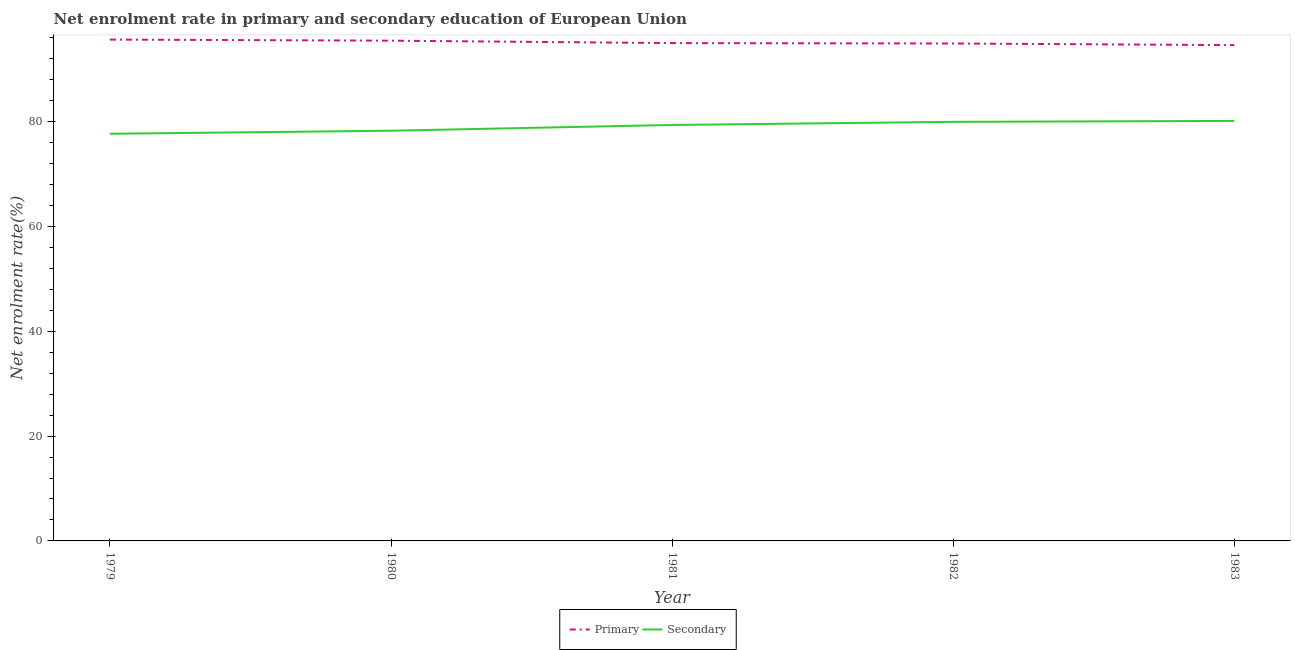Does the line corresponding to enrollment rate in primary education intersect with the line corresponding to enrollment rate in secondary education?
Provide a succinct answer. No. Is the number of lines equal to the number of legend labels?
Give a very brief answer. Yes. What is the enrollment rate in primary education in 1981?
Provide a short and direct response. 94.94. Across all years, what is the maximum enrollment rate in secondary education?
Offer a very short reply. 80.1. Across all years, what is the minimum enrollment rate in primary education?
Your answer should be very brief. 94.56. In which year was the enrollment rate in primary education maximum?
Keep it short and to the point. 1979. What is the total enrollment rate in secondary education in the graph?
Your answer should be compact. 395.23. What is the difference between the enrollment rate in secondary education in 1979 and that in 1983?
Offer a very short reply. -2.45. What is the difference between the enrollment rate in primary education in 1983 and the enrollment rate in secondary education in 1980?
Ensure brevity in your answer.  16.33. What is the average enrollment rate in primary education per year?
Provide a short and direct response. 95.08. In the year 1981, what is the difference between the enrollment rate in secondary education and enrollment rate in primary education?
Make the answer very short. -15.62. What is the ratio of the enrollment rate in secondary education in 1981 to that in 1983?
Your response must be concise. 0.99. Is the enrollment rate in primary education in 1979 less than that in 1983?
Ensure brevity in your answer.  No. Is the difference between the enrollment rate in primary education in 1979 and 1981 greater than the difference between the enrollment rate in secondary education in 1979 and 1981?
Provide a succinct answer. Yes. What is the difference between the highest and the second highest enrollment rate in primary education?
Ensure brevity in your answer.  0.21. What is the difference between the highest and the lowest enrollment rate in secondary education?
Your response must be concise. 2.45. In how many years, is the enrollment rate in primary education greater than the average enrollment rate in primary education taken over all years?
Offer a very short reply. 2. Does the enrollment rate in secondary education monotonically increase over the years?
Your answer should be compact. Yes. Is the enrollment rate in primary education strictly greater than the enrollment rate in secondary education over the years?
Keep it short and to the point. Yes. How many lines are there?
Ensure brevity in your answer.  2. How many years are there in the graph?
Your answer should be compact. 5. Are the values on the major ticks of Y-axis written in scientific E-notation?
Offer a very short reply. No. Does the graph contain grids?
Your answer should be very brief. No. How many legend labels are there?
Your response must be concise. 2. How are the legend labels stacked?
Your response must be concise. Horizontal. What is the title of the graph?
Provide a short and direct response. Net enrolment rate in primary and secondary education of European Union. Does "Money lenders" appear as one of the legend labels in the graph?
Your answer should be compact. No. What is the label or title of the Y-axis?
Your answer should be very brief. Net enrolment rate(%). What is the Net enrolment rate(%) in Primary in 1979?
Your response must be concise. 95.61. What is the Net enrolment rate(%) of Secondary in 1979?
Make the answer very short. 77.65. What is the Net enrolment rate(%) of Primary in 1980?
Provide a succinct answer. 95.4. What is the Net enrolment rate(%) in Secondary in 1980?
Make the answer very short. 78.23. What is the Net enrolment rate(%) of Primary in 1981?
Your answer should be very brief. 94.94. What is the Net enrolment rate(%) in Secondary in 1981?
Make the answer very short. 79.33. What is the Net enrolment rate(%) in Primary in 1982?
Your answer should be very brief. 94.87. What is the Net enrolment rate(%) in Secondary in 1982?
Offer a terse response. 79.92. What is the Net enrolment rate(%) of Primary in 1983?
Your response must be concise. 94.56. What is the Net enrolment rate(%) of Secondary in 1983?
Give a very brief answer. 80.1. Across all years, what is the maximum Net enrolment rate(%) of Primary?
Offer a terse response. 95.61. Across all years, what is the maximum Net enrolment rate(%) in Secondary?
Your answer should be compact. 80.1. Across all years, what is the minimum Net enrolment rate(%) of Primary?
Your response must be concise. 94.56. Across all years, what is the minimum Net enrolment rate(%) in Secondary?
Provide a succinct answer. 77.65. What is the total Net enrolment rate(%) of Primary in the graph?
Your response must be concise. 475.38. What is the total Net enrolment rate(%) in Secondary in the graph?
Make the answer very short. 395.23. What is the difference between the Net enrolment rate(%) in Primary in 1979 and that in 1980?
Ensure brevity in your answer.  0.21. What is the difference between the Net enrolment rate(%) of Secondary in 1979 and that in 1980?
Provide a short and direct response. -0.58. What is the difference between the Net enrolment rate(%) of Primary in 1979 and that in 1981?
Your response must be concise. 0.67. What is the difference between the Net enrolment rate(%) in Secondary in 1979 and that in 1981?
Ensure brevity in your answer.  -1.68. What is the difference between the Net enrolment rate(%) in Primary in 1979 and that in 1982?
Keep it short and to the point. 0.75. What is the difference between the Net enrolment rate(%) of Secondary in 1979 and that in 1982?
Provide a succinct answer. -2.27. What is the difference between the Net enrolment rate(%) of Primary in 1979 and that in 1983?
Provide a short and direct response. 1.06. What is the difference between the Net enrolment rate(%) of Secondary in 1979 and that in 1983?
Offer a very short reply. -2.45. What is the difference between the Net enrolment rate(%) in Primary in 1980 and that in 1981?
Make the answer very short. 0.46. What is the difference between the Net enrolment rate(%) of Secondary in 1980 and that in 1981?
Offer a very short reply. -1.1. What is the difference between the Net enrolment rate(%) of Primary in 1980 and that in 1982?
Your answer should be very brief. 0.54. What is the difference between the Net enrolment rate(%) of Secondary in 1980 and that in 1982?
Provide a succinct answer. -1.69. What is the difference between the Net enrolment rate(%) in Primary in 1980 and that in 1983?
Provide a succinct answer. 0.85. What is the difference between the Net enrolment rate(%) of Secondary in 1980 and that in 1983?
Offer a very short reply. -1.87. What is the difference between the Net enrolment rate(%) of Primary in 1981 and that in 1982?
Give a very brief answer. 0.08. What is the difference between the Net enrolment rate(%) of Secondary in 1981 and that in 1982?
Your answer should be compact. -0.6. What is the difference between the Net enrolment rate(%) of Primary in 1981 and that in 1983?
Your answer should be very brief. 0.39. What is the difference between the Net enrolment rate(%) in Secondary in 1981 and that in 1983?
Ensure brevity in your answer.  -0.77. What is the difference between the Net enrolment rate(%) of Primary in 1982 and that in 1983?
Offer a very short reply. 0.31. What is the difference between the Net enrolment rate(%) in Secondary in 1982 and that in 1983?
Offer a very short reply. -0.18. What is the difference between the Net enrolment rate(%) of Primary in 1979 and the Net enrolment rate(%) of Secondary in 1980?
Make the answer very short. 17.38. What is the difference between the Net enrolment rate(%) in Primary in 1979 and the Net enrolment rate(%) in Secondary in 1981?
Provide a short and direct response. 16.29. What is the difference between the Net enrolment rate(%) in Primary in 1979 and the Net enrolment rate(%) in Secondary in 1982?
Your answer should be compact. 15.69. What is the difference between the Net enrolment rate(%) in Primary in 1979 and the Net enrolment rate(%) in Secondary in 1983?
Offer a very short reply. 15.51. What is the difference between the Net enrolment rate(%) in Primary in 1980 and the Net enrolment rate(%) in Secondary in 1981?
Ensure brevity in your answer.  16.08. What is the difference between the Net enrolment rate(%) in Primary in 1980 and the Net enrolment rate(%) in Secondary in 1982?
Your answer should be very brief. 15.48. What is the difference between the Net enrolment rate(%) in Primary in 1980 and the Net enrolment rate(%) in Secondary in 1983?
Provide a succinct answer. 15.3. What is the difference between the Net enrolment rate(%) of Primary in 1981 and the Net enrolment rate(%) of Secondary in 1982?
Offer a very short reply. 15.02. What is the difference between the Net enrolment rate(%) of Primary in 1981 and the Net enrolment rate(%) of Secondary in 1983?
Your answer should be very brief. 14.84. What is the difference between the Net enrolment rate(%) of Primary in 1982 and the Net enrolment rate(%) of Secondary in 1983?
Offer a very short reply. 14.77. What is the average Net enrolment rate(%) in Primary per year?
Offer a very short reply. 95.08. What is the average Net enrolment rate(%) in Secondary per year?
Provide a short and direct response. 79.05. In the year 1979, what is the difference between the Net enrolment rate(%) of Primary and Net enrolment rate(%) of Secondary?
Ensure brevity in your answer.  17.96. In the year 1980, what is the difference between the Net enrolment rate(%) of Primary and Net enrolment rate(%) of Secondary?
Your response must be concise. 17.17. In the year 1981, what is the difference between the Net enrolment rate(%) in Primary and Net enrolment rate(%) in Secondary?
Ensure brevity in your answer.  15.62. In the year 1982, what is the difference between the Net enrolment rate(%) in Primary and Net enrolment rate(%) in Secondary?
Offer a very short reply. 14.94. In the year 1983, what is the difference between the Net enrolment rate(%) in Primary and Net enrolment rate(%) in Secondary?
Provide a succinct answer. 14.46. What is the ratio of the Net enrolment rate(%) in Secondary in 1979 to that in 1981?
Ensure brevity in your answer.  0.98. What is the ratio of the Net enrolment rate(%) in Primary in 1979 to that in 1982?
Your answer should be very brief. 1.01. What is the ratio of the Net enrolment rate(%) of Secondary in 1979 to that in 1982?
Offer a terse response. 0.97. What is the ratio of the Net enrolment rate(%) of Primary in 1979 to that in 1983?
Give a very brief answer. 1.01. What is the ratio of the Net enrolment rate(%) of Secondary in 1979 to that in 1983?
Offer a very short reply. 0.97. What is the ratio of the Net enrolment rate(%) of Primary in 1980 to that in 1981?
Provide a succinct answer. 1. What is the ratio of the Net enrolment rate(%) in Secondary in 1980 to that in 1981?
Ensure brevity in your answer.  0.99. What is the ratio of the Net enrolment rate(%) of Secondary in 1980 to that in 1982?
Offer a very short reply. 0.98. What is the ratio of the Net enrolment rate(%) in Primary in 1980 to that in 1983?
Provide a short and direct response. 1.01. What is the ratio of the Net enrolment rate(%) of Secondary in 1980 to that in 1983?
Provide a succinct answer. 0.98. What is the ratio of the Net enrolment rate(%) of Primary in 1981 to that in 1982?
Ensure brevity in your answer.  1. What is the ratio of the Net enrolment rate(%) of Primary in 1981 to that in 1983?
Your response must be concise. 1. What is the ratio of the Net enrolment rate(%) of Secondary in 1981 to that in 1983?
Your answer should be compact. 0.99. What is the difference between the highest and the second highest Net enrolment rate(%) in Primary?
Provide a short and direct response. 0.21. What is the difference between the highest and the second highest Net enrolment rate(%) of Secondary?
Provide a succinct answer. 0.18. What is the difference between the highest and the lowest Net enrolment rate(%) in Primary?
Ensure brevity in your answer.  1.06. What is the difference between the highest and the lowest Net enrolment rate(%) in Secondary?
Offer a terse response. 2.45. 